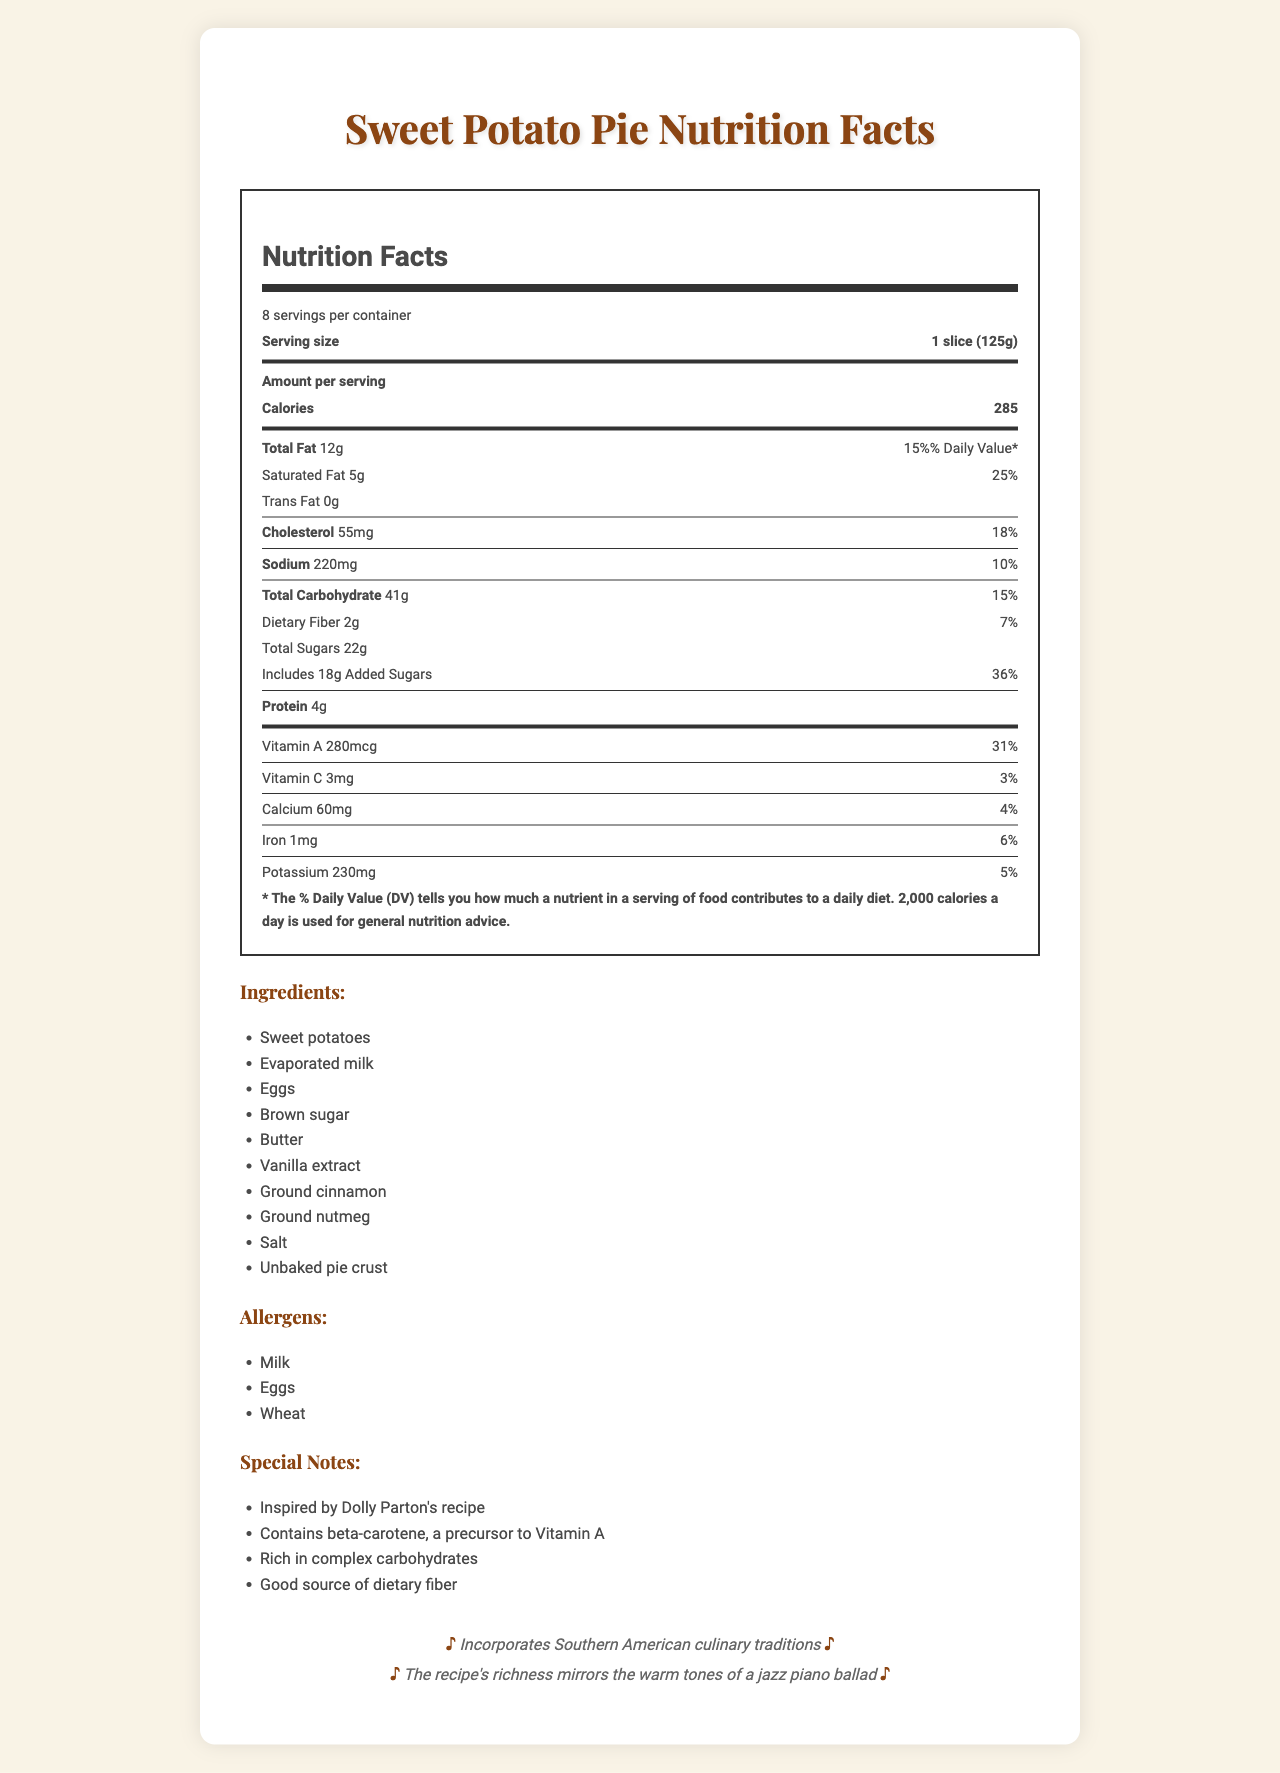what is the serving size of the sweet potato pie? The serving size is directly listed as "1 slice (125g)" in the document.
Answer: 1 slice (125g) how many servings are there per container? The document specifies "8 servings per container."
Answer: 8 what is the amount of total Fat in one serving of sweet potato pie? The amount of total fat per serving is listed as "12g."
Answer: 12g how much Vitamin A does one serving provide? The amount of Vitamin A per serving is 280mcg, which is also 31% of the daily value (DV).
Answer: 280mcg, 31% DV how much protein is in one slice of the sweet potato pie? The amount of protein is stated as 4g per serving.
Answer: 4g what are the main ingredients listed in the sweet potato pie? The main ingredients are listed in the document.
Answer: Sweet potatoes, Evaporated milk, Eggs, Brown sugar, Butter, Vanilla extract, Ground cinnamon, Ground nutmeg, Salt, Unbaked pie crust how much saturated fat is in one serving? There are 5g of saturated fat per serving.
Answer: 5g how many calories does one slice of the sweet potato pie contain? One slice contains 285 calories.
Answer: 285 which nutrients have added percentages of the daily value clearly noted? A. Total Fat, Saturated Fat, Cholesterol, Sodium, Total Carbohydrate, Added Sugars B. Total Fat, Cholesterol, Protein C. Saturated Fat, Added Sugars, Vitamin A, Vitamin C The document lists percentages of the daily value for Total Fat, Saturated Fat, Cholesterol, Sodium, Total Carbohydrate, and Added Sugars.
Answer: A which ingredients are common allergens in the sweet potato pie? A. Peanuts, Milk, Eggs B. Milk, Eggs, Wheat C. Seafood, Soy, Wheat The document specifies the allergens as Milk, Eggs, and Wheat.
Answer: B Is evaporated milk used in the sweet potato pie recipe? The ingredient list includes evaporated milk.
Answer: Yes does one serving provide any dietary fiber? The document states that one serving contains 2g of dietary fiber.
Answer: Yes describe the document in summary. The document covers comprehensive nutritional data, highlights key ingredients and allergens, and mentions the cultural and musical connections to Dolly Parton and Tennessee.
Answer: The document is a detailed Nutrition Facts Label for a sweet potato pie inspired by Dolly Parton’s recipe. It provides nutritional information per serving, including calories, fats, cholesterol, sodium, carbohydrates, sugars, protein, and various vitamins and minerals. The document also lists the ingredients, allergens, special notes, and the culinary inspiration rooted in Southern American traditions. what is the inspiration behind this sweet potato pie recipe? The document highlights that the pie incorporates Southern American culinary traditions and reflects the comfort food style of Tennessee, which is Dolly Parton's home state.
Answer: Southern American culinary traditions, specifically Tennessee, Dolly Parton’s home state how much Iron is there in one serving? The document states that there is 1mg of Iron per serving, which is 6% of the daily value.
Answer: 1mg, 6% DV which vitamins and minerals are included in the nutrition label of the sweet potato pie? The listed vitamins and minerals include Vitamin A, Vitamin C, Calcium, Iron, and Potassium.
Answer: Vitamin A, Vitamin C, Calcium, Iron, Potassium What inspired the richness of the recipe? The document mentions that the recipe's richness mirrors the warm tones of a jazz piano ballad.
Answer: The recipe's richness mirrors the warm tones of a jazz piano ballad what kind of music is connected with the sweet potato pie? The document mentions that sweet potato pie is often mentioned in blues and country songs.
Answer: Blues and country songs what is the sodium content per serving? The document states that the sodium content is 220mg per serving, which is 10% of the daily value.
Answer: 220mg, 10% DV Are the musical connections stated as "Sweet potato pie is a staple in Southern jazz music"? The document actually mentions that sweet potato pie is a staple in Southern soul food and is often mentioned in blues and country songs.
Answer: No how many grams of carbohydrates are in one slice of sweet potato pie? One slice contains 41g of carbohydrates, which is 15% of the daily value.
Answer: 41g, 15% DV Are there any calories from fat in one serving? The document does not provide specific information regarding calories from fat.
Answer: Cannot be determined Is butter used in the sweet potato pie recipe? Butter is listed as one of the ingredients in the recipe.
Answer: Yes 